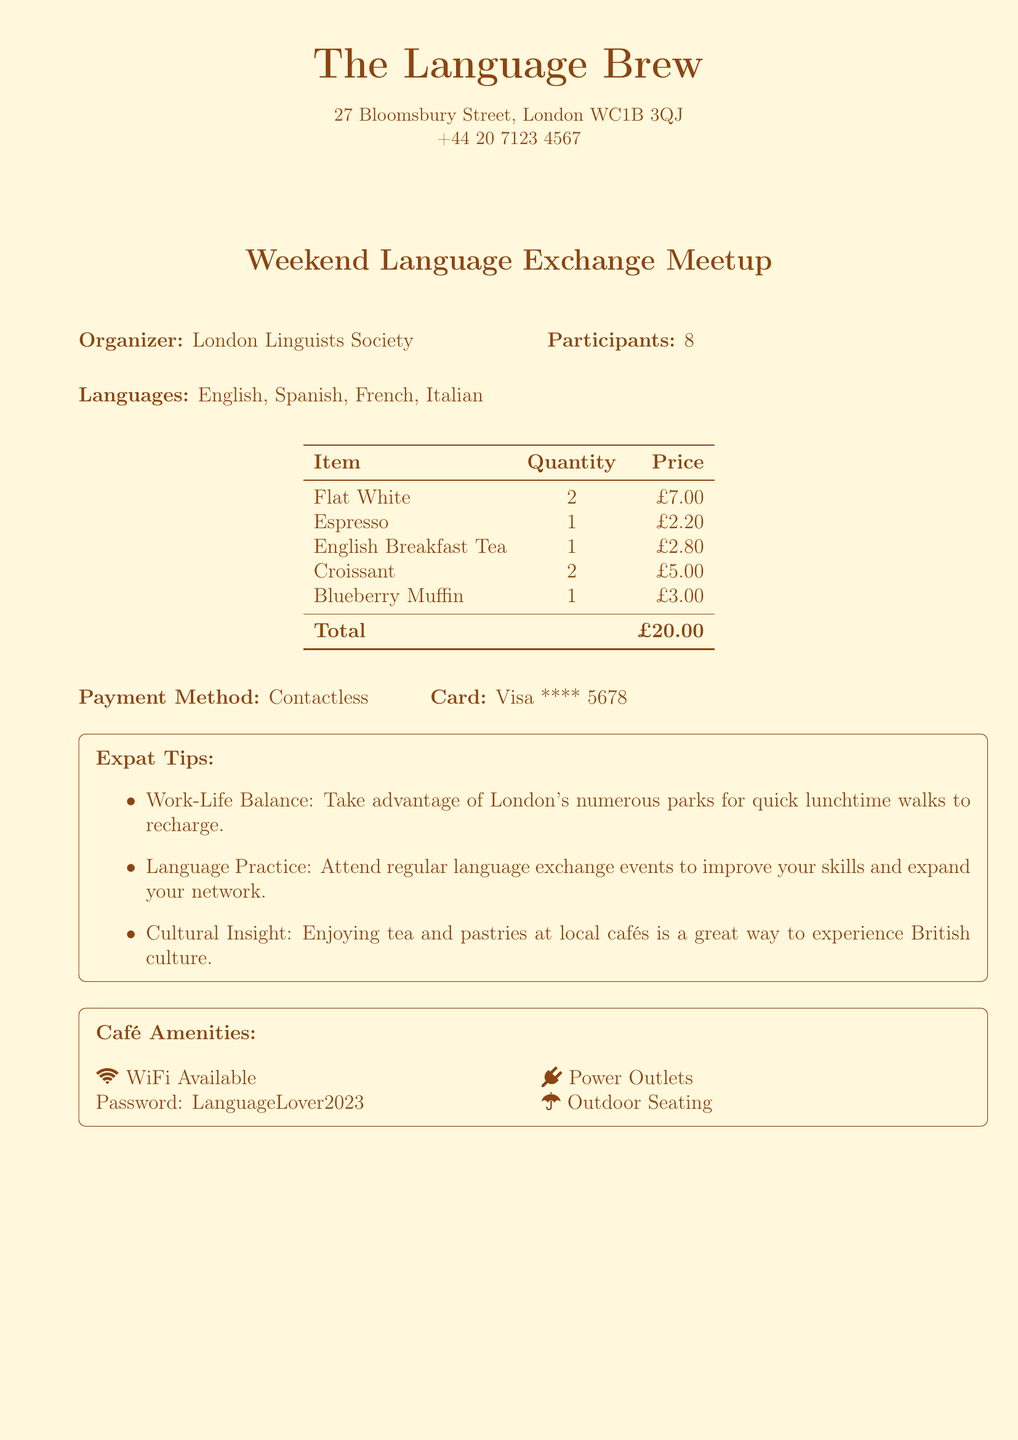What is the name of the café? The café is mentioned prominently at the top of the document.
Answer: The Language Brew What is the date of the meetup? The date is listed in the header section next to the café information.
Answer: 2023-05-20 How many participants were there? The participants are mentioned in the event details section of the document.
Answer: 8 What was the total amount spent? The total amount is the sum of all items purchased, shown at the bottom of the receipt.
Answer: £20.00 What are the languages practiced at the event? The languages are listed in the event details section.
Answer: English, Spanish, French, Italian What type of payment was used? The payment method is indicated in the payment section of the document.
Answer: Contactless What is the Wi-Fi password? The Wi-Fi password is explicitly mentioned in the café amenities section.
Answer: LanguageLover2023 What type of food was purchased? The items on the receipt include both drinks and pastries.
Answer: Coffee and pastries What is one work-life balance tip provided? Tips are listed under the expat tips section which covers work-life balance.
Answer: Take advantage of London's numerous parks for quick lunchtime walks to recharge 